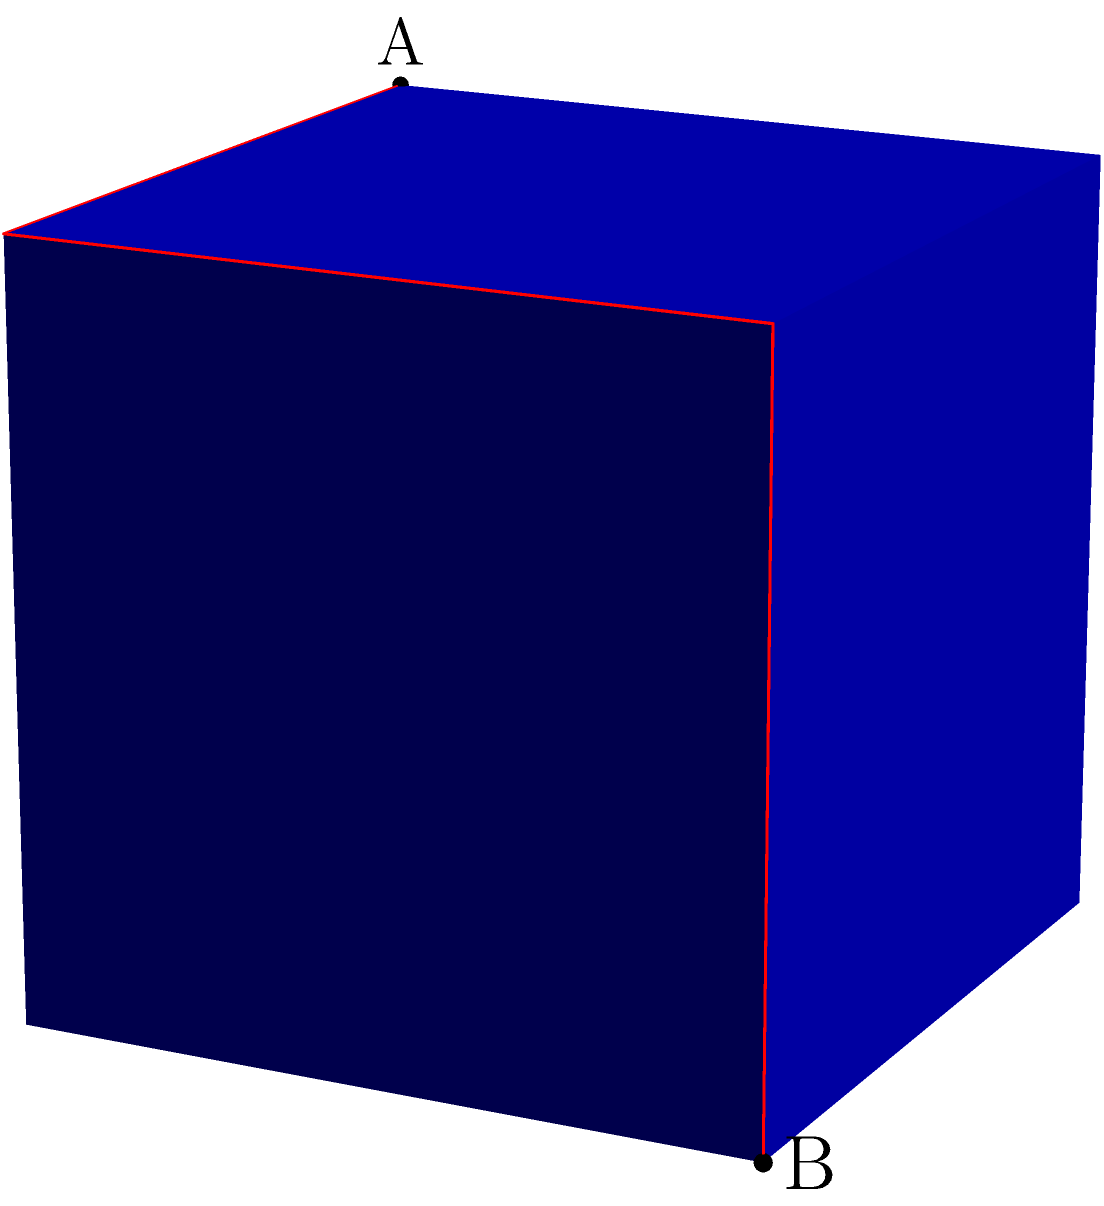Consider a unit cube with points A(0,0,1) and B(1,1,0) on its surface. Without the aid of interactive 3D models, determine the shortest path between A and B along the cube's surface. What is the length of this path? To find the shortest path between two points on a cube's surface, we need to consider the "unfolding" of the cube:

1) Visualize the path:
   The shortest path will be a straight line when the cube is unfolded.

2) Identify the faces:
   Point A is on the top face, and point B is on the front face.

3) Unfold the cube:
   Imagine "unfolding" the top face onto the same plane as the front face.

4) Calculate the path:
   The path goes from the top face (0,0,1) to the edge (1,0,1), then to (1,1,1), and finally to (1,1,0).

5) Apply the Pythagorean theorem:
   a) From (0,0,1) to (1,0,1): distance = 1
   b) From (1,0,1) to (1,1,1): distance = 1
   c) From (1,1,1) to (1,1,0): distance = 1

6) Sum up the distances:
   Total distance = 1 + 1 + 1 = 3

7) Verify:
   This path follows the cube's surface and connects A to B.

Without an interactive model, this spatial reasoning is challenging, emphasizing the difficulty of visualizing 3D problems on 2D mediums like traditional books.
Answer: 3 units 